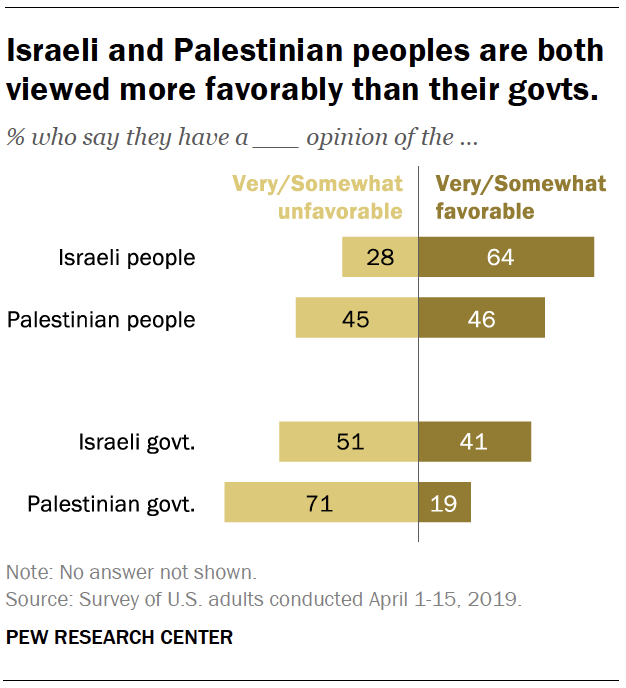Draw attention to some important aspects in this diagram. The ratio of the largest dark brown bar to the smallest light brown bar is approximately 0.671527778... According to the survey, 64% of Israeli people have either very favorable or somewhat favorable opinions. 